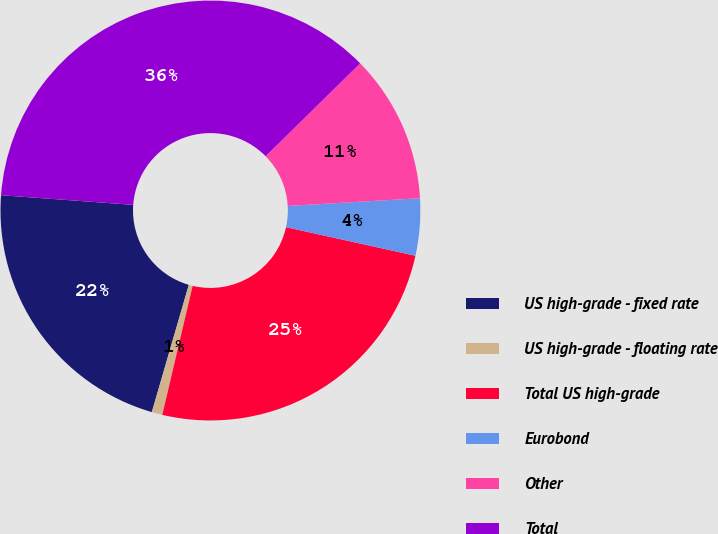Convert chart. <chart><loc_0><loc_0><loc_500><loc_500><pie_chart><fcel>US high-grade - fixed rate<fcel>US high-grade - floating rate<fcel>Total US high-grade<fcel>Eurobond<fcel>Other<fcel>Total<nl><fcel>21.66%<fcel>0.82%<fcel>25.23%<fcel>4.39%<fcel>11.43%<fcel>36.48%<nl></chart> 